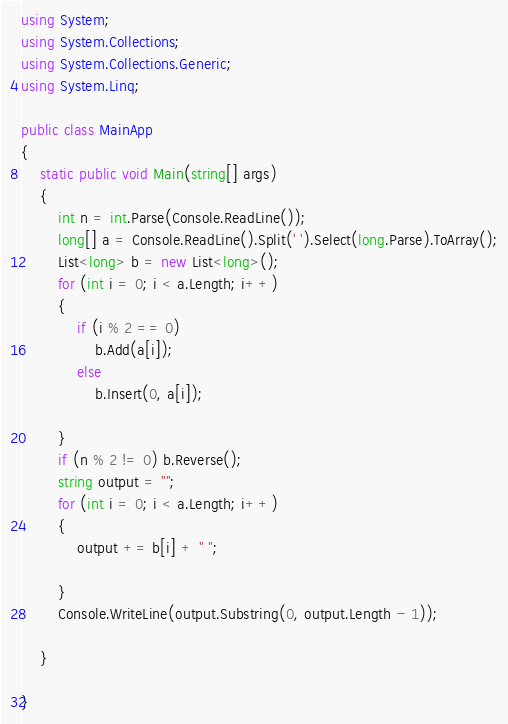<code> <loc_0><loc_0><loc_500><loc_500><_C#_>using System;
using System.Collections;
using System.Collections.Generic;
using System.Linq;

public class MainApp
{
    static public void Main(string[] args)
    {
        int n = int.Parse(Console.ReadLine());
        long[] a = Console.ReadLine().Split(' ').Select(long.Parse).ToArray();
        List<long> b = new List<long>();
        for (int i = 0; i < a.Length; i++)
        {
            if (i % 2 == 0)
                b.Add(a[i]);
            else
                b.Insert(0, a[i]);
            
        }
        if (n % 2 != 0) b.Reverse();
        string output = "";
        for (int i = 0; i < a.Length; i++)
        {
            output += b[i] + " ";

        }
        Console.WriteLine(output.Substring(0, output.Length - 1));

    }

}</code> 